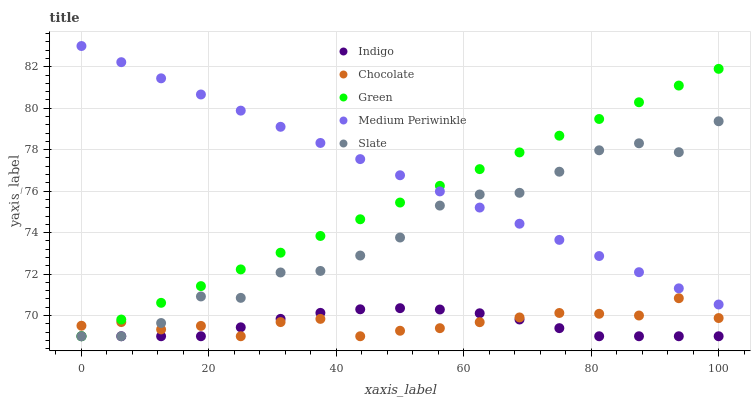Does Indigo have the minimum area under the curve?
Answer yes or no. Yes. Does Medium Periwinkle have the maximum area under the curve?
Answer yes or no. Yes. Does Slate have the minimum area under the curve?
Answer yes or no. No. Does Slate have the maximum area under the curve?
Answer yes or no. No. Is Green the smoothest?
Answer yes or no. Yes. Is Slate the roughest?
Answer yes or no. Yes. Is Indigo the smoothest?
Answer yes or no. No. Is Indigo the roughest?
Answer yes or no. No. Does Green have the lowest value?
Answer yes or no. Yes. Does Medium Periwinkle have the lowest value?
Answer yes or no. No. Does Medium Periwinkle have the highest value?
Answer yes or no. Yes. Does Slate have the highest value?
Answer yes or no. No. Is Indigo less than Medium Periwinkle?
Answer yes or no. Yes. Is Medium Periwinkle greater than Chocolate?
Answer yes or no. Yes. Does Medium Periwinkle intersect Slate?
Answer yes or no. Yes. Is Medium Periwinkle less than Slate?
Answer yes or no. No. Is Medium Periwinkle greater than Slate?
Answer yes or no. No. Does Indigo intersect Medium Periwinkle?
Answer yes or no. No. 